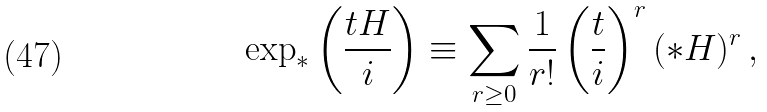<formula> <loc_0><loc_0><loc_500><loc_500>\exp _ { \ast } \left ( \frac { t H } { i } \right ) \equiv \sum _ { r \geq 0 } \frac { 1 } { r ! } \left ( \frac { t } { i } \right ) ^ { r } ( \ast H ) ^ { r } \, ,</formula> 